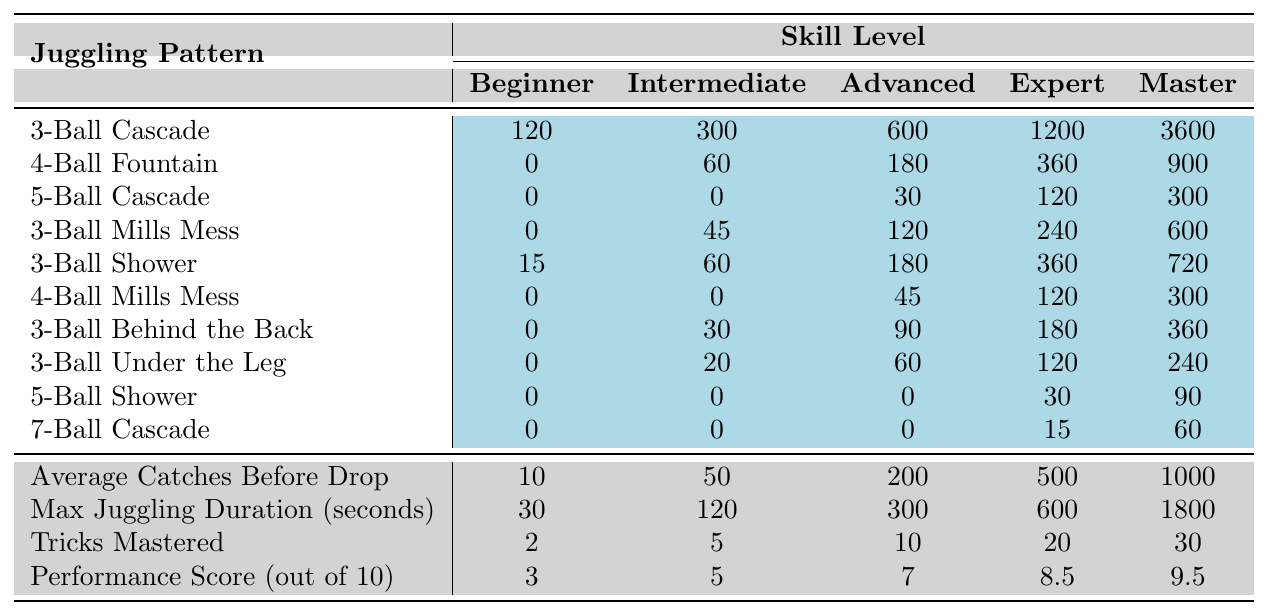What is the maximum number of catches for a Beginner in the 5-Ball Cascade? Referring to the table under the 5-Ball Cascade for the Beginner skill level, the value is 0.
Answer: 0 How many tricks can an Expert juggle? The table specifies that the number of tricks mastered at the Expert skill level is 20.
Answer: 20 What is the average juggling duration for an Advanced performer? The table indicates that the Max Juggling Duration for Advanced performers is 300 seconds.
Answer: 300 seconds How many more catches, on average, can a Master perform compared to a Beginner? For Masters, the Average Catches Before Drop is 1000, and for Beginners, it is 10. The difference is 1000 - 10 = 990.
Answer: 990 Is it true that the Performance Score for an Advanced performer is greater than 6? Checking the Performance Score for Advanced performers, which is 7, it is indeed greater than 6.
Answer: Yes What is the total maximum juggling duration for all skill levels combined? The maximum durations are 30, 120, 300, 600, and 1800 seconds. The total is 30 + 120 + 300 + 600 + 1800 = 2850 seconds.
Answer: 2850 seconds Which juggling pattern shows the greatest increase in catches from Beginner to Master? The 3-Ball Cascade shows an increase from 120 to 3600 catches, which is an increase of 3480 catches. Checking other patterns will show they do not exceed this increase.
Answer: 3480 How would you describe the performance score trend as the skill level increases from Beginner to Master? Observing the Performance Scores: 3, 5, 7, 8.5, and 9.5, we see an increasing trend, indicating better performance with higher skill levels.
Answer: Increasing trend What are the total tricks mastered for Intermediate and Advanced performers together? For Intermediate, 5 tricks are mastered, and for Advanced, it's 10. Adding them gives 5 + 10 = 15 tricks.
Answer: 15 tricks What is the highest juggling score among the performance scores for all skill levels? The table shows the highest performance score is 9.5 for Masters.
Answer: 9.5 